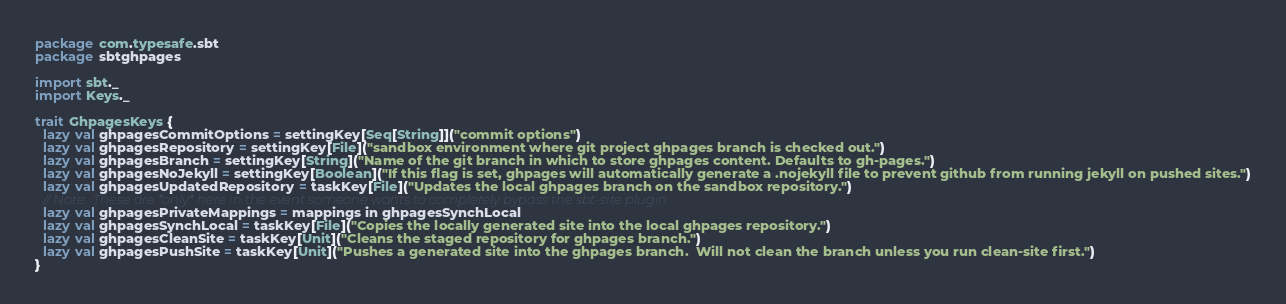Convert code to text. <code><loc_0><loc_0><loc_500><loc_500><_Scala_>package com.typesafe.sbt
package sbtghpages

import sbt._
import Keys._

trait GhpagesKeys {
  lazy val ghpagesCommitOptions = settingKey[Seq[String]]("commit options")
  lazy val ghpagesRepository = settingKey[File]("sandbox environment where git project ghpages branch is checked out.")
  lazy val ghpagesBranch = settingKey[String]("Name of the git branch in which to store ghpages content. Defaults to gh-pages.")
  lazy val ghpagesNoJekyll = settingKey[Boolean]("If this flag is set, ghpages will automatically generate a .nojekyll file to prevent github from running jekyll on pushed sites.")
  lazy val ghpagesUpdatedRepository = taskKey[File]("Updates the local ghpages branch on the sandbox repository.")
  // Note:  These are *only* here in the event someone wants to completely bypass the sbt-site plugin.
  lazy val ghpagesPrivateMappings = mappings in ghpagesSynchLocal
  lazy val ghpagesSynchLocal = taskKey[File]("Copies the locally generated site into the local ghpages repository.")
  lazy val ghpagesCleanSite = taskKey[Unit]("Cleans the staged repository for ghpages branch.")
  lazy val ghpagesPushSite = taskKey[Unit]("Pushes a generated site into the ghpages branch.  Will not clean the branch unless you run clean-site first.")
}
</code> 